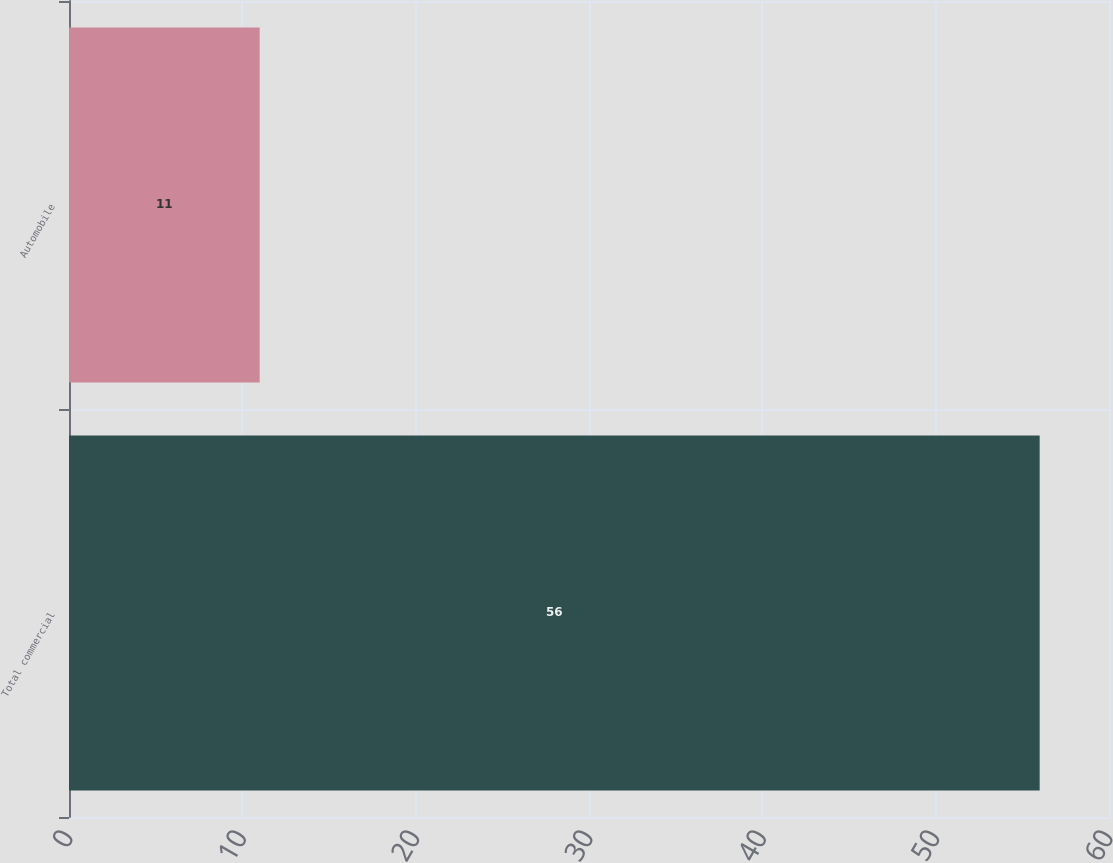<chart> <loc_0><loc_0><loc_500><loc_500><bar_chart><fcel>Total commercial<fcel>Automobile<nl><fcel>56<fcel>11<nl></chart> 